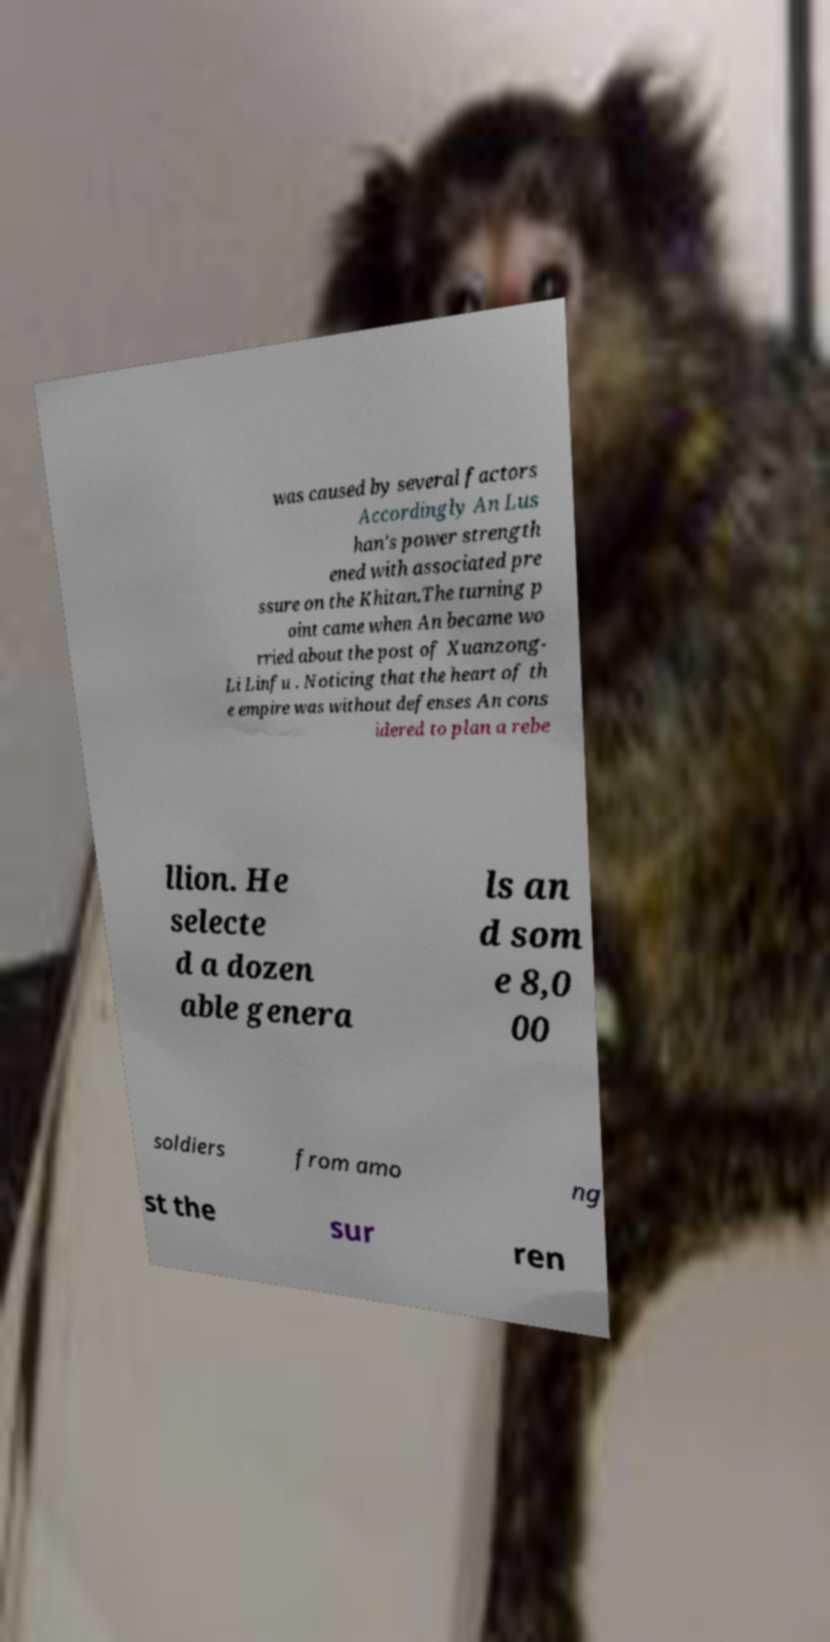Can you accurately transcribe the text from the provided image for me? was caused by several factors Accordingly An Lus han's power strength ened with associated pre ssure on the Khitan.The turning p oint came when An became wo rried about the post of Xuanzong- Li Linfu . Noticing that the heart of th e empire was without defenses An cons idered to plan a rebe llion. He selecte d a dozen able genera ls an d som e 8,0 00 soldiers from amo ng st the sur ren 